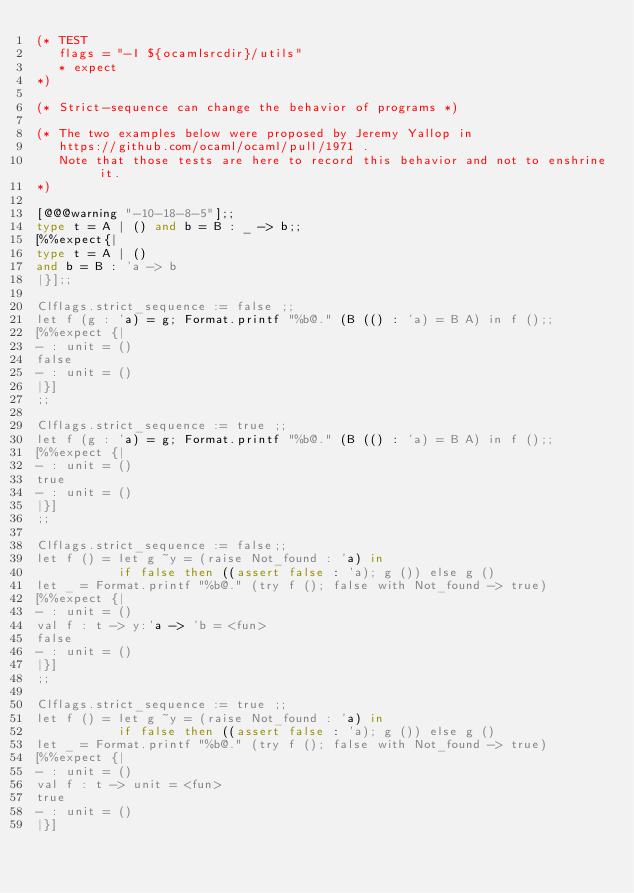<code> <loc_0><loc_0><loc_500><loc_500><_OCaml_>(* TEST
   flags = "-I ${ocamlsrcdir}/utils"
   * expect
*)

(* Strict-sequence can change the behavior of programs *)

(* The two examples below were proposed by Jeremy Yallop in
   https://github.com/ocaml/ocaml/pull/1971 .
   Note that those tests are here to record this behavior and not to enshrine it.
*)

[@@@warning "-10-18-8-5"];;
type t = A | () and b = B : _ -> b;;
[%%expect{|
type t = A | ()
and b = B : 'a -> b
|}];;

Clflags.strict_sequence := false ;;
let f (g : 'a) = g; Format.printf "%b@." (B (() : 'a) = B A) in f ();;
[%%expect {|
- : unit = ()
false
- : unit = ()
|}]
;;

Clflags.strict_sequence := true ;;
let f (g : 'a) = g; Format.printf "%b@." (B (() : 'a) = B A) in f ();;
[%%expect {|
- : unit = ()
true
- : unit = ()
|}]
;;

Clflags.strict_sequence := false;;
let f () = let g ~y = (raise Not_found : 'a) in
           if false then ((assert false : 'a); g ()) else g ()
let _ = Format.printf "%b@." (try f (); false with Not_found -> true)
[%%expect {|
- : unit = ()
val f : t -> y:'a -> 'b = <fun>
false
- : unit = ()
|}]
;;

Clflags.strict_sequence := true ;;
let f () = let g ~y = (raise Not_found : 'a) in
           if false then ((assert false : 'a); g ()) else g ()
let _ = Format.printf "%b@." (try f (); false with Not_found -> true)
[%%expect {|
- : unit = ()
val f : t -> unit = <fun>
true
- : unit = ()
|}]
</code> 